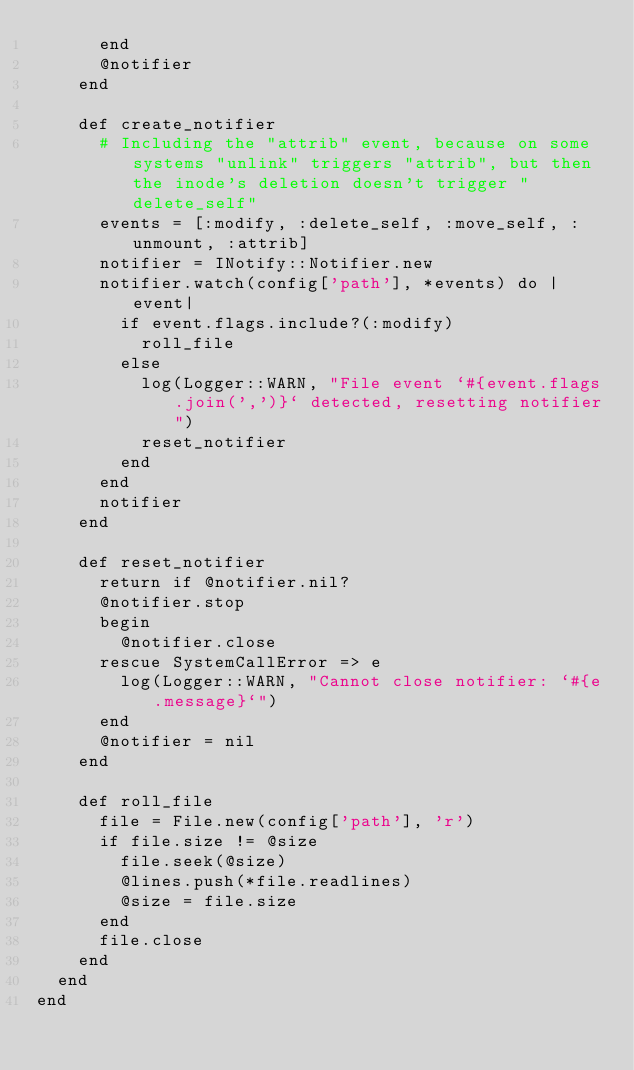<code> <loc_0><loc_0><loc_500><loc_500><_Ruby_>      end
      @notifier
    end

    def create_notifier
      # Including the "attrib" event, because on some systems "unlink" triggers "attrib", but then the inode's deletion doesn't trigger "delete_self"
      events = [:modify, :delete_self, :move_self, :unmount, :attrib]
      notifier = INotify::Notifier.new
      notifier.watch(config['path'], *events) do |event|
        if event.flags.include?(:modify)
          roll_file
        else
          log(Logger::WARN, "File event `#{event.flags.join(',')}` detected, resetting notifier")
          reset_notifier
        end
      end
      notifier
    end

    def reset_notifier
      return if @notifier.nil?
      @notifier.stop
      begin
        @notifier.close
      rescue SystemCallError => e
        log(Logger::WARN, "Cannot close notifier: `#{e.message}`")
      end
      @notifier = nil
    end

    def roll_file
      file = File.new(config['path'], 'r')
      if file.size != @size
        file.seek(@size)
        @lines.push(*file.readlines)
        @size = file.size
      end
      file.close
    end
  end
end
</code> 